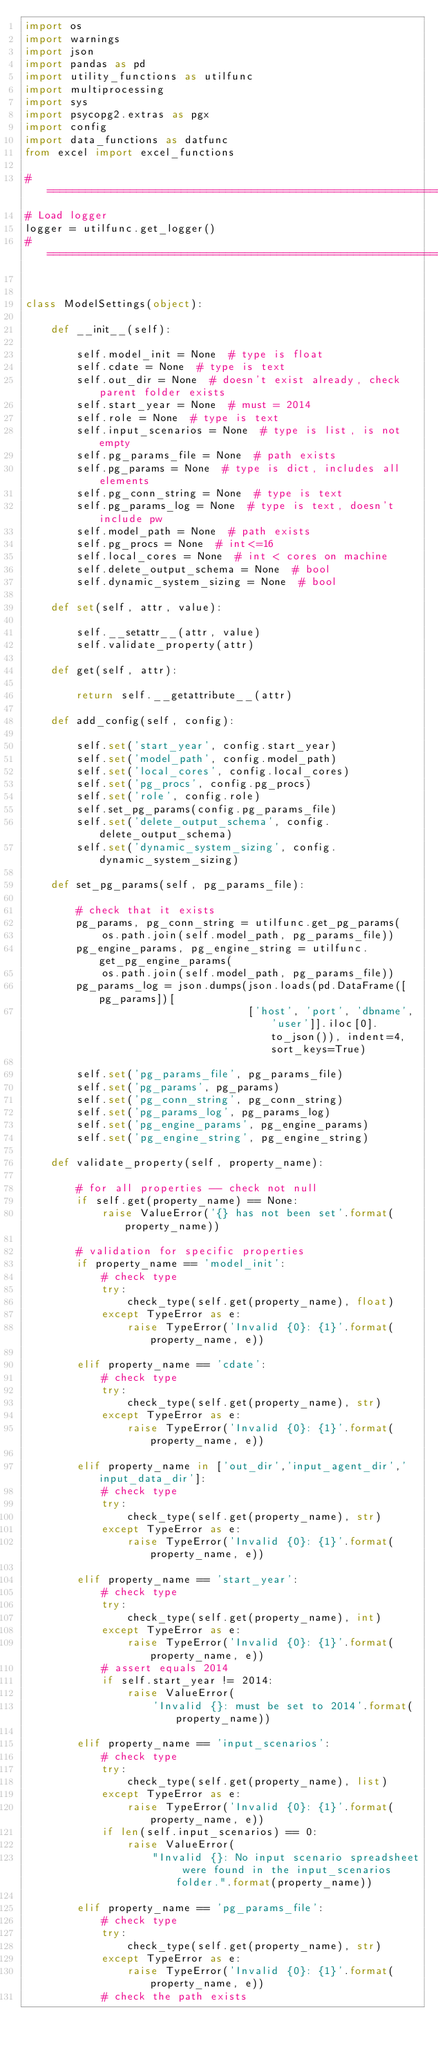<code> <loc_0><loc_0><loc_500><loc_500><_Python_>import os
import warnings
import json
import pandas as pd
import utility_functions as utilfunc
import multiprocessing
import sys
import psycopg2.extras as pgx
import config
import data_functions as datfunc
from excel import excel_functions

#==============================================================================
# Load logger
logger = utilfunc.get_logger()
#==============================================================================


class ModelSettings(object):

    def __init__(self):

        self.model_init = None  # type is float
        self.cdate = None  # type is text
        self.out_dir = None  # doesn't exist already, check parent folder exists
        self.start_year = None  # must = 2014
        self.role = None  # type is text
        self.input_scenarios = None  # type is list, is not empty
        self.pg_params_file = None  # path exists
        self.pg_params = None  # type is dict, includes all elements
        self.pg_conn_string = None  # type is text
        self.pg_params_log = None  # type is text, doesn't include pw
        self.model_path = None  # path exists
        self.pg_procs = None  # int<=16
        self.local_cores = None  # int < cores on machine
        self.delete_output_schema = None  # bool
        self.dynamic_system_sizing = None  # bool

    def set(self, attr, value):

        self.__setattr__(attr, value)
        self.validate_property(attr)

    def get(self, attr):

        return self.__getattribute__(attr)

    def add_config(self, config):

        self.set('start_year', config.start_year)
        self.set('model_path', config.model_path)
        self.set('local_cores', config.local_cores)
        self.set('pg_procs', config.pg_procs)
        self.set('role', config.role)
        self.set_pg_params(config.pg_params_file)
        self.set('delete_output_schema', config.delete_output_schema)
        self.set('dynamic_system_sizing', config.dynamic_system_sizing)

    def set_pg_params(self, pg_params_file):

        # check that it exists
        pg_params, pg_conn_string = utilfunc.get_pg_params(
            os.path.join(self.model_path, pg_params_file))
        pg_engine_params, pg_engine_string = utilfunc.get_pg_engine_params(
            os.path.join(self.model_path, pg_params_file))
        pg_params_log = json.dumps(json.loads(pd.DataFrame([pg_params])[
                                   ['host', 'port', 'dbname', 'user']].iloc[0].to_json()), indent=4, sort_keys=True)

        self.set('pg_params_file', pg_params_file)
        self.set('pg_params', pg_params)
        self.set('pg_conn_string', pg_conn_string)
        self.set('pg_params_log', pg_params_log)
        self.set('pg_engine_params', pg_engine_params)
        self.set('pg_engine_string', pg_engine_string)

    def validate_property(self, property_name):

        # for all properties -- check not null
        if self.get(property_name) == None:
            raise ValueError('{} has not been set'.format(property_name))

        # validation for specific properties
        if property_name == 'model_init':
            # check type
            try:
                check_type(self.get(property_name), float)
            except TypeError as e:
                raise TypeError('Invalid {0}: {1}'.format(property_name, e))

        elif property_name == 'cdate':
            # check type
            try:
                check_type(self.get(property_name), str)
            except TypeError as e:
                raise TypeError('Invalid {0}: {1}'.format(property_name, e))

        elif property_name in ['out_dir','input_agent_dir','input_data_dir']:
            # check type
            try:
                check_type(self.get(property_name), str)
            except TypeError as e:
                raise TypeError('Invalid {0}: {1}'.format(property_name, e))

        elif property_name == 'start_year':
            # check type
            try:
                check_type(self.get(property_name), int)
            except TypeError as e:
                raise TypeError('Invalid {0}: {1}'.format(property_name, e))
            # assert equals 2014
            if self.start_year != 2014:
                raise ValueError(
                    'Invalid {}: must be set to 2014'.format(property_name))

        elif property_name == 'input_scenarios':
            # check type
            try:
                check_type(self.get(property_name), list)
            except TypeError as e:
                raise TypeError('Invalid {0}: {1}'.format(property_name, e))
            if len(self.input_scenarios) == 0:
                raise ValueError(
                    "Invalid {}: No input scenario spreadsheet were found in the input_scenarios folder.".format(property_name))

        elif property_name == 'pg_params_file':
            # check type
            try:
                check_type(self.get(property_name), str)
            except TypeError as e:
                raise TypeError('Invalid {0}: {1}'.format(property_name, e))
            # check the path exists</code> 